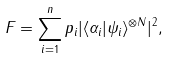Convert formula to latex. <formula><loc_0><loc_0><loc_500><loc_500>F = \sum _ { i = 1 } ^ { n } p _ { i } | \langle \alpha _ { i } | \psi _ { i } \rangle ^ { \otimes N } | ^ { 2 } ,</formula> 